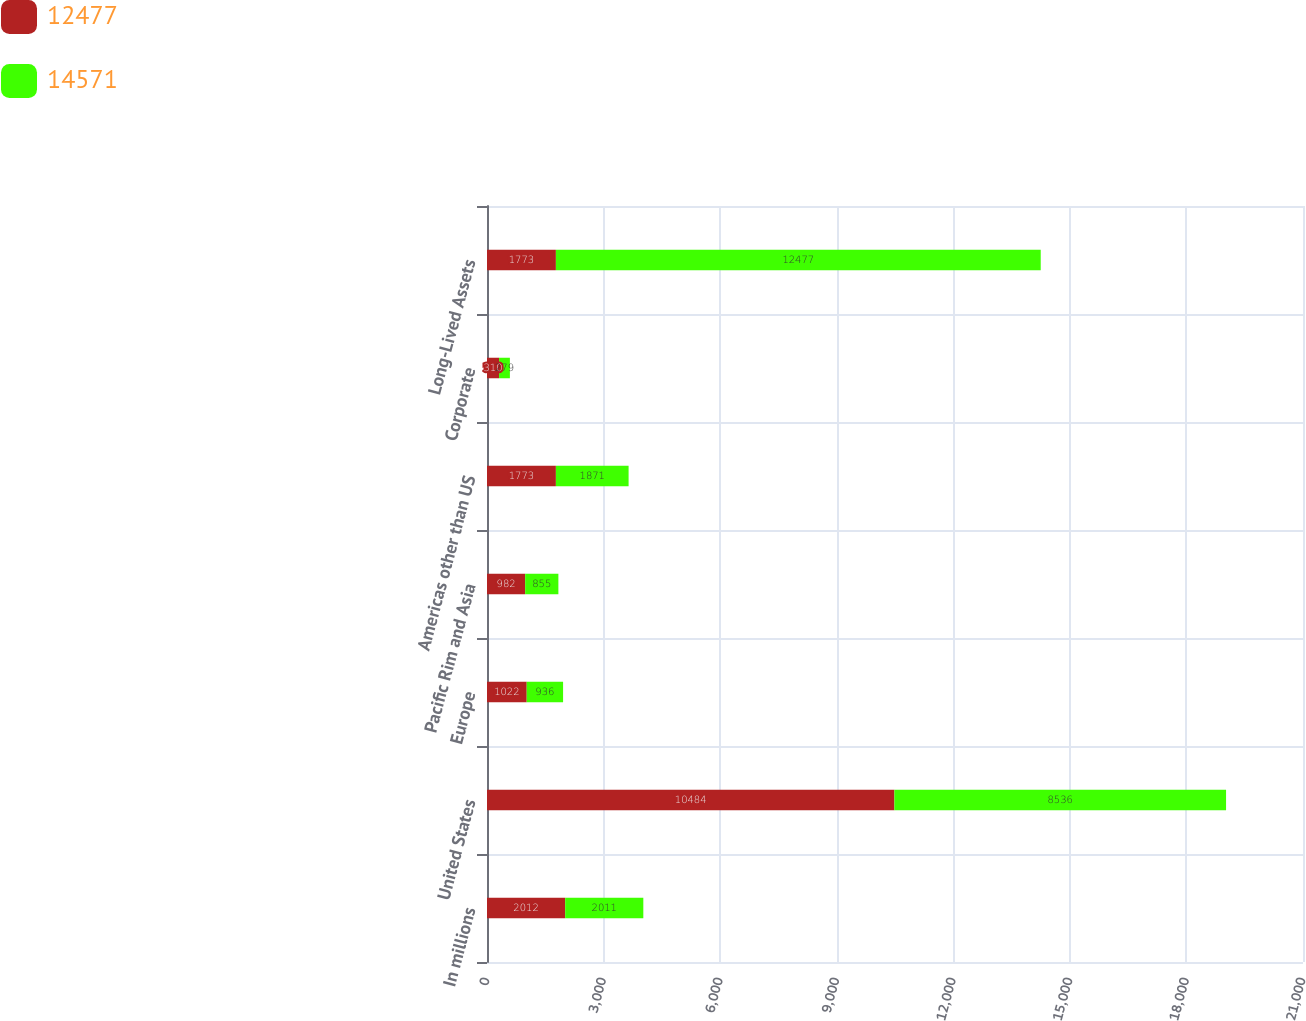<chart> <loc_0><loc_0><loc_500><loc_500><stacked_bar_chart><ecel><fcel>In millions<fcel>United States<fcel>Europe<fcel>Pacific Rim and Asia<fcel>Americas other than US<fcel>Corporate<fcel>Long-Lived Assets<nl><fcel>12477<fcel>2012<fcel>10484<fcel>1022<fcel>982<fcel>1773<fcel>310<fcel>1773<nl><fcel>14571<fcel>2011<fcel>8536<fcel>936<fcel>855<fcel>1871<fcel>279<fcel>12477<nl></chart> 